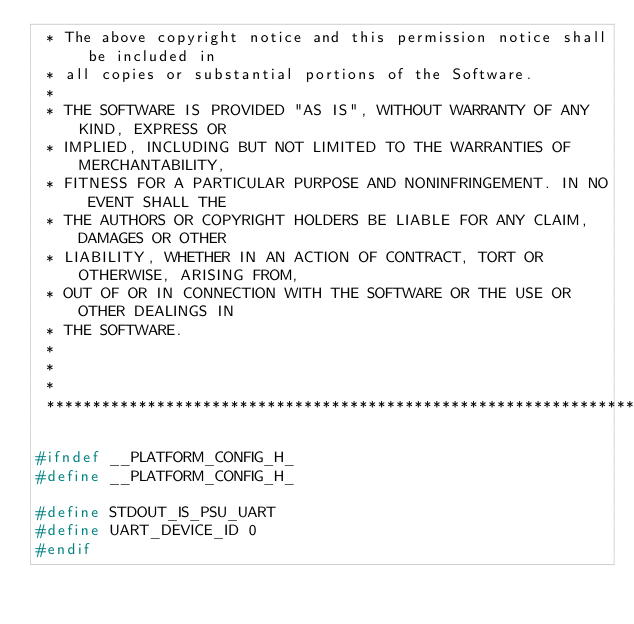Convert code to text. <code><loc_0><loc_0><loc_500><loc_500><_C_> * The above copyright notice and this permission notice shall be included in
 * all copies or substantial portions of the Software.
 *
 * THE SOFTWARE IS PROVIDED "AS IS", WITHOUT WARRANTY OF ANY KIND, EXPRESS OR
 * IMPLIED, INCLUDING BUT NOT LIMITED TO THE WARRANTIES OF MERCHANTABILITY,
 * FITNESS FOR A PARTICULAR PURPOSE AND NONINFRINGEMENT. IN NO EVENT SHALL THE
 * THE AUTHORS OR COPYRIGHT HOLDERS BE LIABLE FOR ANY CLAIM, DAMAGES OR OTHER
 * LIABILITY, WHETHER IN AN ACTION OF CONTRACT, TORT OR OTHERWISE, ARISING FROM,
 * OUT OF OR IN CONNECTION WITH THE SOFTWARE OR THE USE OR OTHER DEALINGS IN
 * THE SOFTWARE.
 *
 *
 *
 ******************************************************************************/

#ifndef __PLATFORM_CONFIG_H_
#define __PLATFORM_CONFIG_H_

#define STDOUT_IS_PSU_UART
#define UART_DEVICE_ID 0
#endif
</code> 